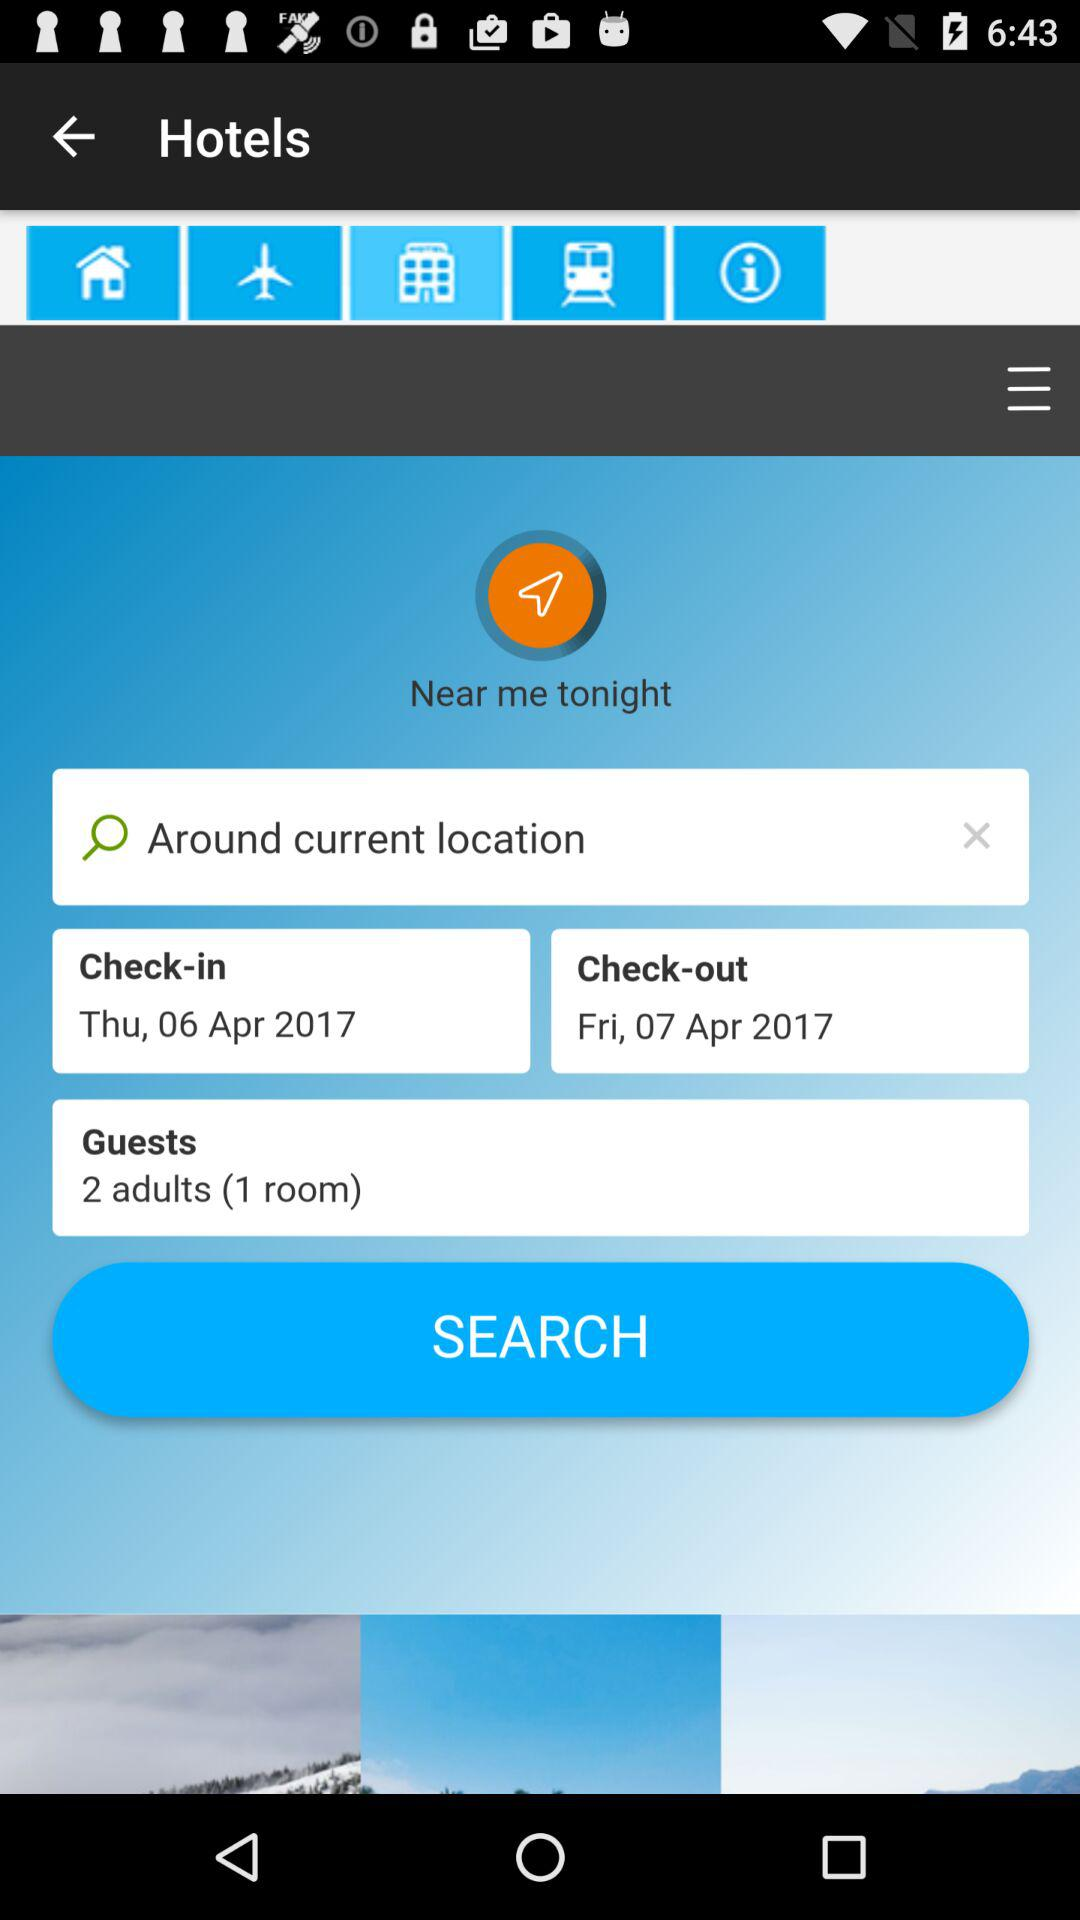What is the number of rooms? The number of rooms is 1. 